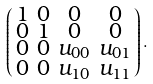<formula> <loc_0><loc_0><loc_500><loc_500>\left ( \begin{smallmatrix} 1 & 0 & 0 & 0 \\ 0 & 1 & 0 & 0 \\ 0 & 0 & u _ { 0 0 } & u _ { 0 1 } \\ 0 & 0 & u _ { 1 0 } & u _ { 1 1 } \\ \end{smallmatrix} \right ) .</formula> 